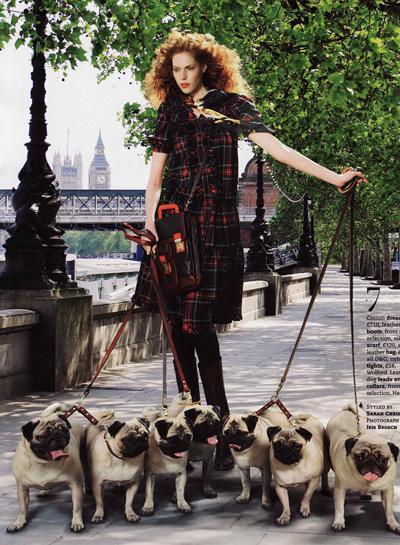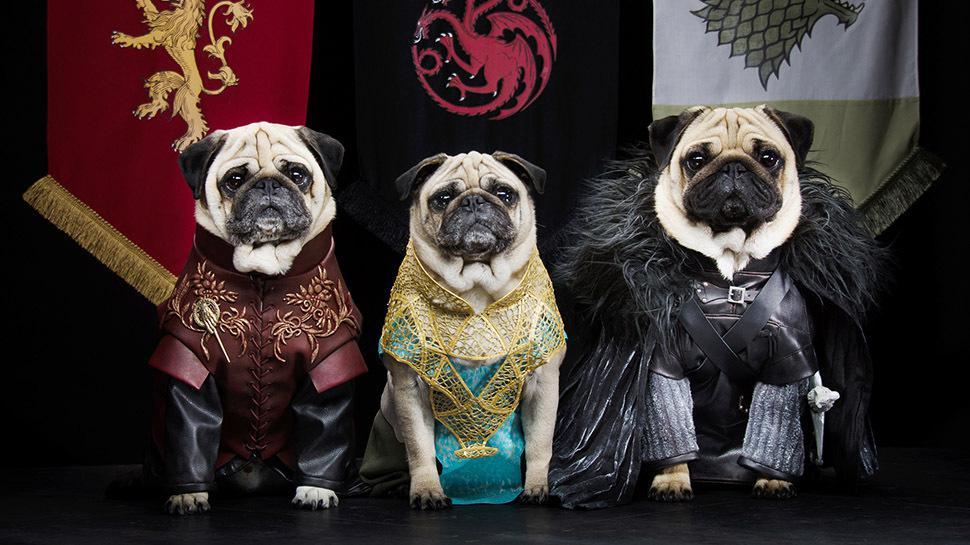The first image is the image on the left, the second image is the image on the right. Examine the images to the left and right. Is the description "At least one of the images contains only a single pug." accurate? Answer yes or no. No. The first image is the image on the left, the second image is the image on the right. Given the left and right images, does the statement "In at least one image, at least one pug is wearing clothes." hold true? Answer yes or no. Yes. 